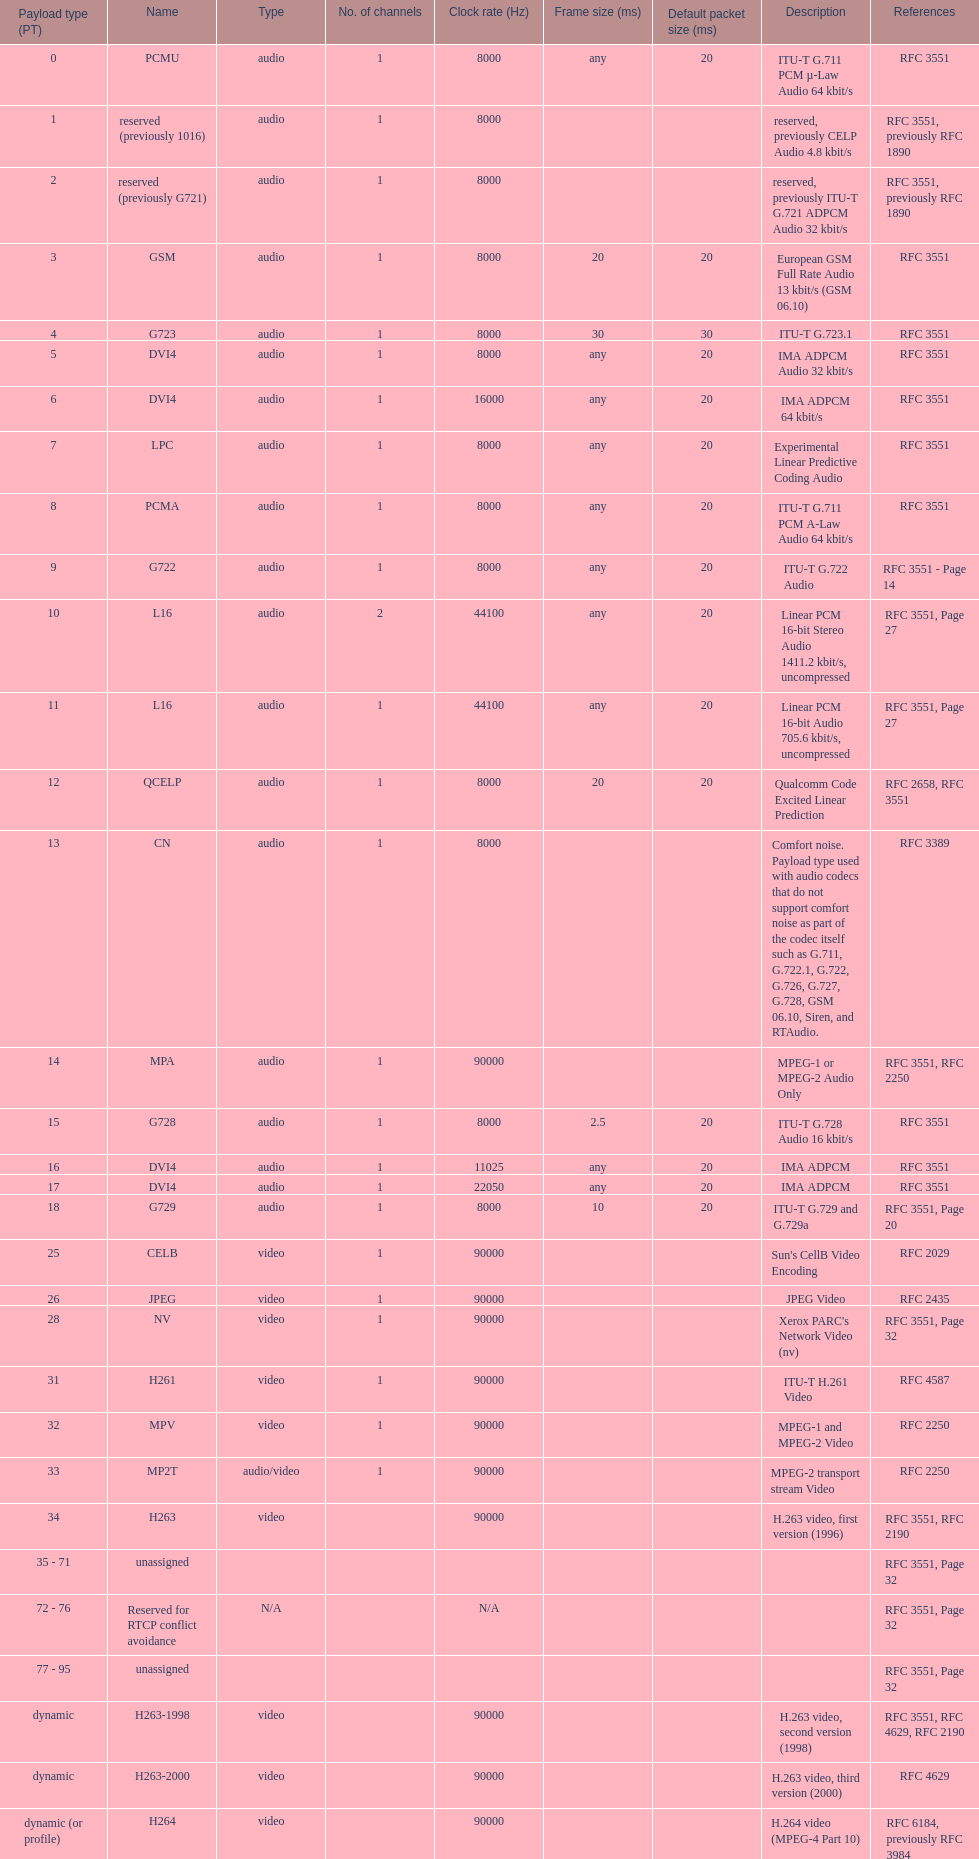What is the mean number of channels? 1. 